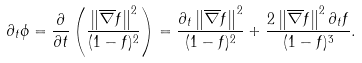<formula> <loc_0><loc_0><loc_500><loc_500>\partial _ { t } \phi = \frac { \partial } { \partial { t } } \left ( \frac { \left \| \overline { \nabla } { f } \right \| ^ { 2 } } { ( 1 - f ) ^ { 2 } } \right ) = \frac { \partial _ { t } \left \| \overline { \nabla } { f } \right \| ^ { 2 } } { ( 1 - f ) ^ { 2 } } + \frac { 2 \left \| \overline { \nabla } { f } \right \| ^ { 2 } \partial _ { t } f } { ( 1 - f ) ^ { 3 } } .</formula> 